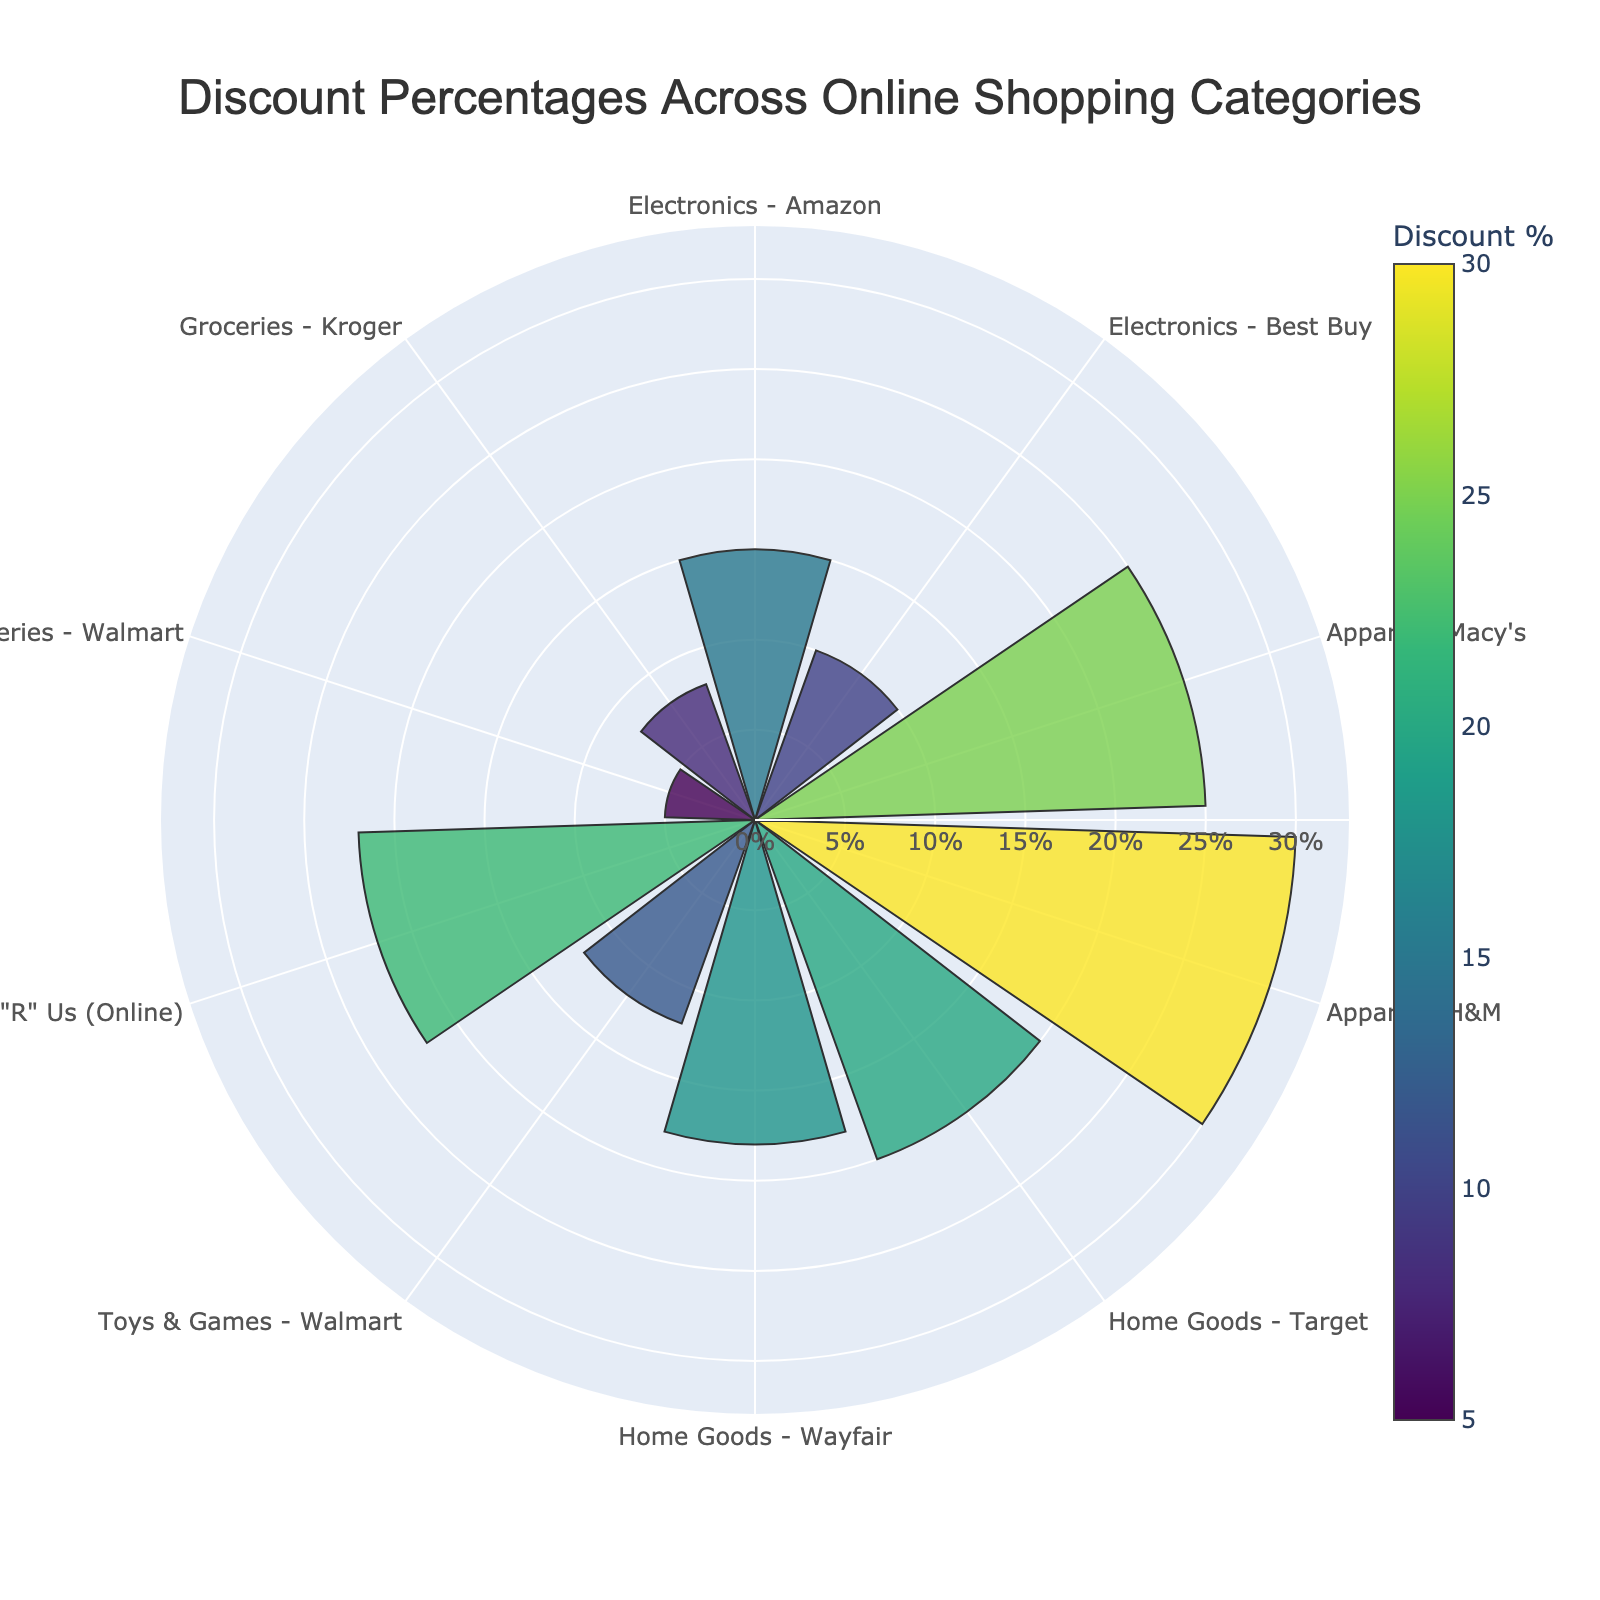What is the title of the figure? The title of the figure is typically placed at the top and provides a summary of what the chart represents. Looking at the figure, the title reads "Discount Percentages Across Online Shopping Categories".
Answer: Discount Percentages Across Online Shopping Categories How many categories are compared in the figure? You can count the number of distinct labels on the angular axis to find the number of categories. There are ten different categories shown in the plot.
Answer: Ten Which category has the highest discount percentage? By observing the radial length of the bars and the color gradient, you can identify the category with the longest bar and darkest color. The category "Apparel - H&M" shows the highest discount percentage.
Answer: Apparel - H&M What is the discount percentage for "Toys & Games - Toys 'R' Us (Online)"? Look for the "Toys & Games - Toys 'R' Us (Online)" label around the angular axis and refer to the radial value for this category. The radial axis shows a discount of 22%.
Answer: 22% Which category has a lower discount percentage, "Electronics - Amazon" or "Electronics - Best Buy"? By comparing the radial lengths of the bars for "Electronics - Amazon" and "Electronics - Best Buy", "Electronics - Amazon" has a discount percentage of 15% while "Electronics - Best Buy" has a discount percentage of 10%. 15% is greater than 10%, so "Electronics - Best Buy" has a lower discount percentage.
Answer: Electronics - Best Buy What is the average discount percentage for Apparel categories? Identify the discount percentages for both Apparel categories: "Apparel - Macy's" (25%) and "Apparel - H&M" (30%). Average these values by summing them and then dividing by the number of categories. (25 + 30) / 2 = 27.5%.
Answer: 27.5% What is the range of the radial axis in the figure? The range of the radial axis can be observed by looking at the maximum value indicated and any markings shown. The maximum radial range is slightly above the highest discount percentage (30%), which shows that the range is a bit above 30%.
Answer: Slightly above 30% Which category has the lowest discount percentage and what is the value? Find the smallest bar in terms of radial length and the lightest color. The "Groceries - Walmart" category shows the lowest discount percentage with a value of 5%.
Answer: Groceries - Walmart, 5% What is the total discount percentage if you sum up all the categories related to Toys & Games? Identify the discount percentages for the toys and games categories: "Toys & Games - Walmart" (12%) and "Toys & Games - Toys 'R' Us (Online)" (22%). Sum these values: 12 + 22 = 34%.
Answer: 34% Do the Home Goods categories have similar discount percentages? By examining the radial lengths and color intensities for "Home Goods - Target" (20%) and "Home Goods - Wayfair" (18%), the two values are close to each other, indicating similar discounts.
Answer: Yes 